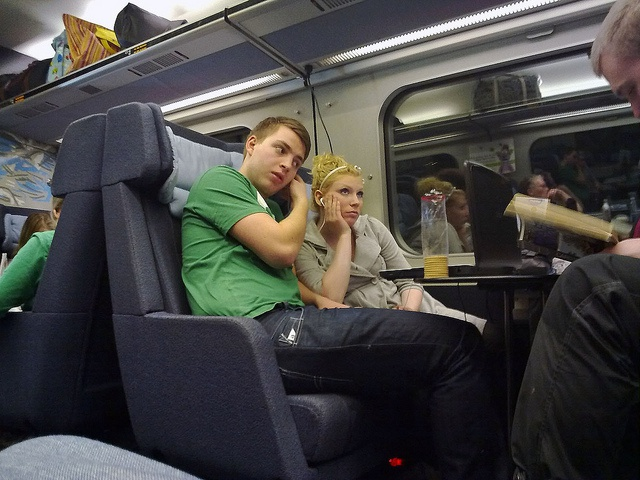Describe the objects in this image and their specific colors. I can see people in darkgreen, black, green, gray, and tan tones, people in darkgreen, black, tan, and darkgray tones, people in darkgreen, tan, darkgray, and gray tones, laptop in darkgreen, black, gray, and darkgray tones, and book in darkgreen, black, tan, and gray tones in this image. 